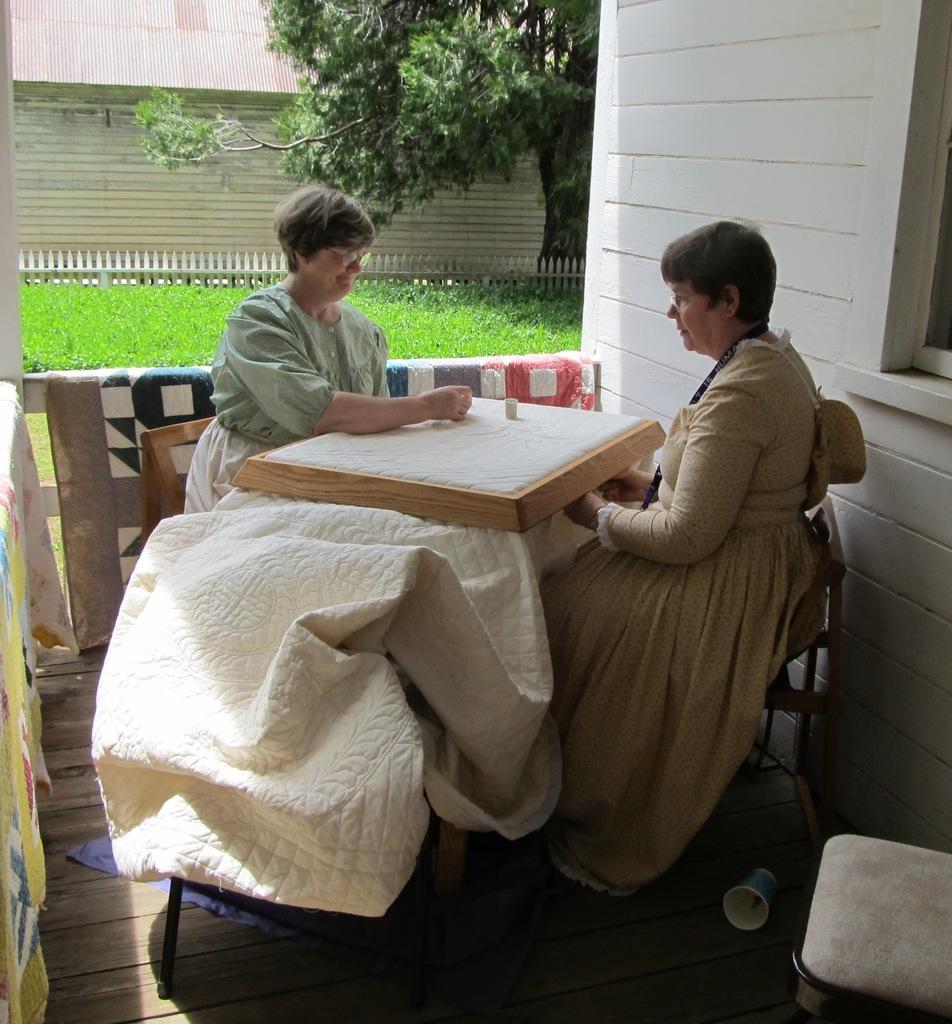Could you give a brief overview of what you see in this image? In the picture I can see two women are sitting on chairs in front of a table. In the background I can see fence, the grass, a tree, houses and some other objects. 